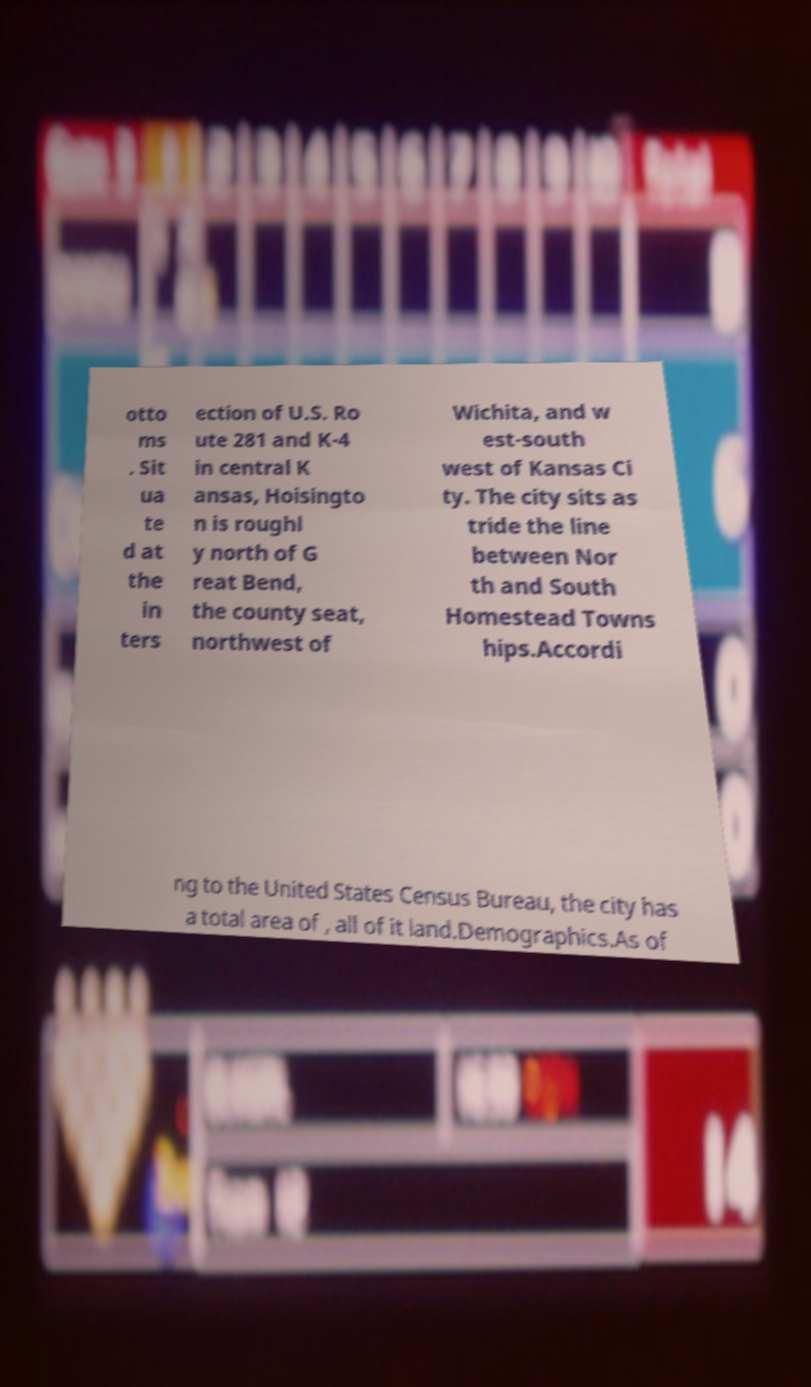Could you extract and type out the text from this image? otto ms . Sit ua te d at the in ters ection of U.S. Ro ute 281 and K-4 in central K ansas, Hoisingto n is roughl y north of G reat Bend, the county seat, northwest of Wichita, and w est-south west of Kansas Ci ty. The city sits as tride the line between Nor th and South Homestead Towns hips.Accordi ng to the United States Census Bureau, the city has a total area of , all of it land.Demographics.As of 